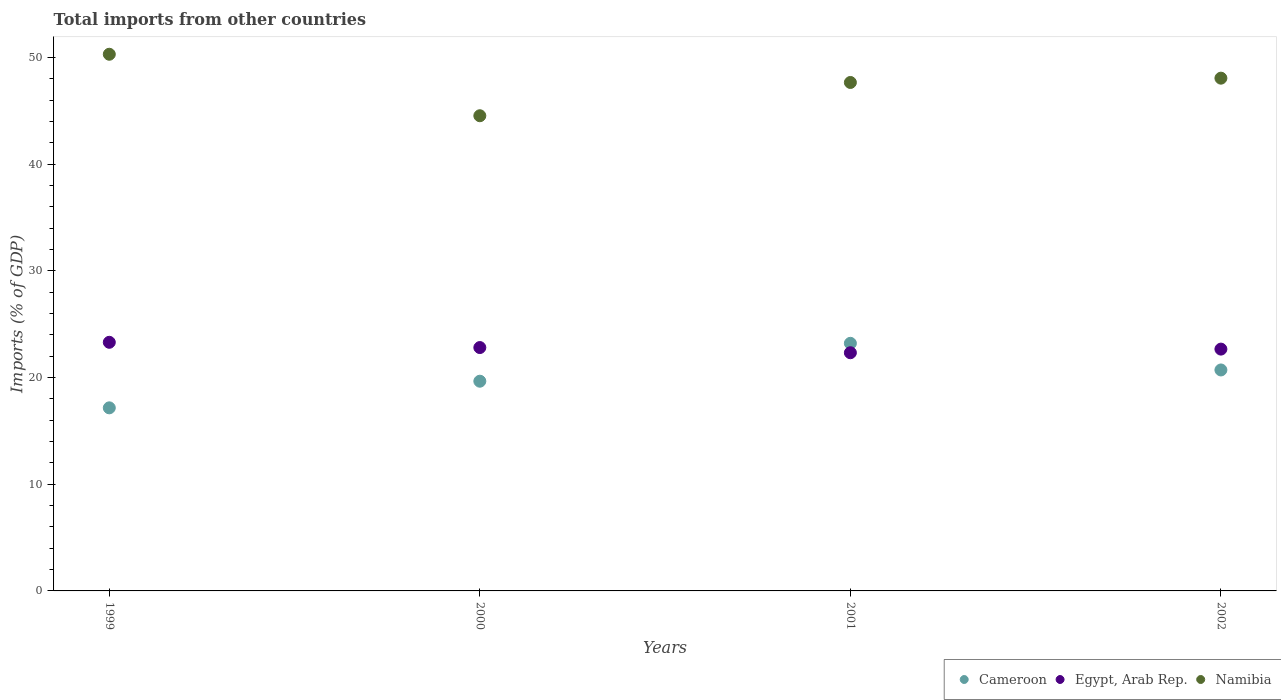How many different coloured dotlines are there?
Your response must be concise. 3. Is the number of dotlines equal to the number of legend labels?
Give a very brief answer. Yes. What is the total imports in Namibia in 2002?
Ensure brevity in your answer.  48.07. Across all years, what is the maximum total imports in Cameroon?
Keep it short and to the point. 23.21. Across all years, what is the minimum total imports in Namibia?
Make the answer very short. 44.55. In which year was the total imports in Cameroon maximum?
Make the answer very short. 2001. In which year was the total imports in Namibia minimum?
Your response must be concise. 2000. What is the total total imports in Egypt, Arab Rep. in the graph?
Offer a very short reply. 91.13. What is the difference between the total imports in Cameroon in 1999 and that in 2000?
Keep it short and to the point. -2.5. What is the difference between the total imports in Namibia in 1999 and the total imports in Egypt, Arab Rep. in 2000?
Your answer should be compact. 27.5. What is the average total imports in Namibia per year?
Keep it short and to the point. 47.65. In the year 2001, what is the difference between the total imports in Cameroon and total imports in Namibia?
Provide a succinct answer. -24.46. In how many years, is the total imports in Namibia greater than 16 %?
Make the answer very short. 4. What is the ratio of the total imports in Cameroon in 2000 to that in 2002?
Your answer should be compact. 0.95. Is the total imports in Egypt, Arab Rep. in 2000 less than that in 2002?
Offer a very short reply. No. Is the difference between the total imports in Cameroon in 2001 and 2002 greater than the difference between the total imports in Namibia in 2001 and 2002?
Offer a terse response. Yes. What is the difference between the highest and the second highest total imports in Cameroon?
Provide a short and direct response. 2.5. What is the difference between the highest and the lowest total imports in Cameroon?
Your answer should be compact. 6.05. In how many years, is the total imports in Cameroon greater than the average total imports in Cameroon taken over all years?
Your answer should be compact. 2. Is the sum of the total imports in Egypt, Arab Rep. in 1999 and 2000 greater than the maximum total imports in Namibia across all years?
Your response must be concise. No. Is it the case that in every year, the sum of the total imports in Egypt, Arab Rep. and total imports in Namibia  is greater than the total imports in Cameroon?
Your answer should be compact. Yes. Is the total imports in Namibia strictly less than the total imports in Egypt, Arab Rep. over the years?
Your answer should be very brief. No. Does the graph contain any zero values?
Provide a succinct answer. No. Does the graph contain grids?
Your answer should be compact. No. Where does the legend appear in the graph?
Make the answer very short. Bottom right. How many legend labels are there?
Give a very brief answer. 3. What is the title of the graph?
Provide a succinct answer. Total imports from other countries. What is the label or title of the X-axis?
Provide a short and direct response. Years. What is the label or title of the Y-axis?
Your answer should be compact. Imports (% of GDP). What is the Imports (% of GDP) in Cameroon in 1999?
Your response must be concise. 17.16. What is the Imports (% of GDP) in Egypt, Arab Rep. in 1999?
Keep it short and to the point. 23.31. What is the Imports (% of GDP) in Namibia in 1999?
Provide a short and direct response. 50.31. What is the Imports (% of GDP) of Cameroon in 2000?
Your answer should be compact. 19.66. What is the Imports (% of GDP) in Egypt, Arab Rep. in 2000?
Keep it short and to the point. 22.82. What is the Imports (% of GDP) of Namibia in 2000?
Your answer should be compact. 44.55. What is the Imports (% of GDP) of Cameroon in 2001?
Make the answer very short. 23.21. What is the Imports (% of GDP) of Egypt, Arab Rep. in 2001?
Provide a short and direct response. 22.33. What is the Imports (% of GDP) in Namibia in 2001?
Your response must be concise. 47.67. What is the Imports (% of GDP) of Cameroon in 2002?
Provide a succinct answer. 20.72. What is the Imports (% of GDP) in Egypt, Arab Rep. in 2002?
Make the answer very short. 22.67. What is the Imports (% of GDP) in Namibia in 2002?
Keep it short and to the point. 48.07. Across all years, what is the maximum Imports (% of GDP) of Cameroon?
Offer a very short reply. 23.21. Across all years, what is the maximum Imports (% of GDP) of Egypt, Arab Rep.?
Keep it short and to the point. 23.31. Across all years, what is the maximum Imports (% of GDP) in Namibia?
Keep it short and to the point. 50.31. Across all years, what is the minimum Imports (% of GDP) of Cameroon?
Keep it short and to the point. 17.16. Across all years, what is the minimum Imports (% of GDP) in Egypt, Arab Rep.?
Ensure brevity in your answer.  22.33. Across all years, what is the minimum Imports (% of GDP) of Namibia?
Ensure brevity in your answer.  44.55. What is the total Imports (% of GDP) in Cameroon in the graph?
Your answer should be very brief. 80.76. What is the total Imports (% of GDP) of Egypt, Arab Rep. in the graph?
Provide a short and direct response. 91.13. What is the total Imports (% of GDP) in Namibia in the graph?
Make the answer very short. 190.61. What is the difference between the Imports (% of GDP) of Cameroon in 1999 and that in 2000?
Ensure brevity in your answer.  -2.5. What is the difference between the Imports (% of GDP) of Egypt, Arab Rep. in 1999 and that in 2000?
Offer a terse response. 0.49. What is the difference between the Imports (% of GDP) in Namibia in 1999 and that in 2000?
Make the answer very short. 5.76. What is the difference between the Imports (% of GDP) of Cameroon in 1999 and that in 2001?
Your answer should be compact. -6.05. What is the difference between the Imports (% of GDP) of Egypt, Arab Rep. in 1999 and that in 2001?
Offer a very short reply. 0.98. What is the difference between the Imports (% of GDP) in Namibia in 1999 and that in 2001?
Keep it short and to the point. 2.65. What is the difference between the Imports (% of GDP) in Cameroon in 1999 and that in 2002?
Give a very brief answer. -3.55. What is the difference between the Imports (% of GDP) of Egypt, Arab Rep. in 1999 and that in 2002?
Offer a very short reply. 0.64. What is the difference between the Imports (% of GDP) of Namibia in 1999 and that in 2002?
Ensure brevity in your answer.  2.24. What is the difference between the Imports (% of GDP) in Cameroon in 2000 and that in 2001?
Offer a very short reply. -3.55. What is the difference between the Imports (% of GDP) of Egypt, Arab Rep. in 2000 and that in 2001?
Keep it short and to the point. 0.49. What is the difference between the Imports (% of GDP) in Namibia in 2000 and that in 2001?
Offer a terse response. -3.12. What is the difference between the Imports (% of GDP) in Cameroon in 2000 and that in 2002?
Make the answer very short. -1.06. What is the difference between the Imports (% of GDP) in Egypt, Arab Rep. in 2000 and that in 2002?
Your answer should be compact. 0.15. What is the difference between the Imports (% of GDP) in Namibia in 2000 and that in 2002?
Ensure brevity in your answer.  -3.52. What is the difference between the Imports (% of GDP) in Cameroon in 2001 and that in 2002?
Provide a short and direct response. 2.5. What is the difference between the Imports (% of GDP) of Egypt, Arab Rep. in 2001 and that in 2002?
Keep it short and to the point. -0.34. What is the difference between the Imports (% of GDP) in Namibia in 2001 and that in 2002?
Offer a very short reply. -0.4. What is the difference between the Imports (% of GDP) in Cameroon in 1999 and the Imports (% of GDP) in Egypt, Arab Rep. in 2000?
Your answer should be very brief. -5.65. What is the difference between the Imports (% of GDP) in Cameroon in 1999 and the Imports (% of GDP) in Namibia in 2000?
Offer a very short reply. -27.39. What is the difference between the Imports (% of GDP) in Egypt, Arab Rep. in 1999 and the Imports (% of GDP) in Namibia in 2000?
Give a very brief answer. -21.24. What is the difference between the Imports (% of GDP) in Cameroon in 1999 and the Imports (% of GDP) in Egypt, Arab Rep. in 2001?
Offer a terse response. -5.17. What is the difference between the Imports (% of GDP) of Cameroon in 1999 and the Imports (% of GDP) of Namibia in 2001?
Your answer should be very brief. -30.51. What is the difference between the Imports (% of GDP) in Egypt, Arab Rep. in 1999 and the Imports (% of GDP) in Namibia in 2001?
Give a very brief answer. -24.36. What is the difference between the Imports (% of GDP) of Cameroon in 1999 and the Imports (% of GDP) of Egypt, Arab Rep. in 2002?
Your answer should be compact. -5.51. What is the difference between the Imports (% of GDP) of Cameroon in 1999 and the Imports (% of GDP) of Namibia in 2002?
Provide a succinct answer. -30.91. What is the difference between the Imports (% of GDP) in Egypt, Arab Rep. in 1999 and the Imports (% of GDP) in Namibia in 2002?
Give a very brief answer. -24.76. What is the difference between the Imports (% of GDP) in Cameroon in 2000 and the Imports (% of GDP) in Egypt, Arab Rep. in 2001?
Offer a terse response. -2.67. What is the difference between the Imports (% of GDP) in Cameroon in 2000 and the Imports (% of GDP) in Namibia in 2001?
Your response must be concise. -28.01. What is the difference between the Imports (% of GDP) in Egypt, Arab Rep. in 2000 and the Imports (% of GDP) in Namibia in 2001?
Your answer should be very brief. -24.85. What is the difference between the Imports (% of GDP) of Cameroon in 2000 and the Imports (% of GDP) of Egypt, Arab Rep. in 2002?
Keep it short and to the point. -3.01. What is the difference between the Imports (% of GDP) in Cameroon in 2000 and the Imports (% of GDP) in Namibia in 2002?
Your answer should be compact. -28.41. What is the difference between the Imports (% of GDP) of Egypt, Arab Rep. in 2000 and the Imports (% of GDP) of Namibia in 2002?
Offer a terse response. -25.26. What is the difference between the Imports (% of GDP) of Cameroon in 2001 and the Imports (% of GDP) of Egypt, Arab Rep. in 2002?
Make the answer very short. 0.54. What is the difference between the Imports (% of GDP) of Cameroon in 2001 and the Imports (% of GDP) of Namibia in 2002?
Keep it short and to the point. -24.86. What is the difference between the Imports (% of GDP) of Egypt, Arab Rep. in 2001 and the Imports (% of GDP) of Namibia in 2002?
Offer a very short reply. -25.74. What is the average Imports (% of GDP) of Cameroon per year?
Give a very brief answer. 20.19. What is the average Imports (% of GDP) of Egypt, Arab Rep. per year?
Your response must be concise. 22.78. What is the average Imports (% of GDP) in Namibia per year?
Give a very brief answer. 47.65. In the year 1999, what is the difference between the Imports (% of GDP) of Cameroon and Imports (% of GDP) of Egypt, Arab Rep.?
Give a very brief answer. -6.15. In the year 1999, what is the difference between the Imports (% of GDP) of Cameroon and Imports (% of GDP) of Namibia?
Make the answer very short. -33.15. In the year 1999, what is the difference between the Imports (% of GDP) in Egypt, Arab Rep. and Imports (% of GDP) in Namibia?
Your response must be concise. -27.01. In the year 2000, what is the difference between the Imports (% of GDP) of Cameroon and Imports (% of GDP) of Egypt, Arab Rep.?
Ensure brevity in your answer.  -3.16. In the year 2000, what is the difference between the Imports (% of GDP) of Cameroon and Imports (% of GDP) of Namibia?
Your answer should be compact. -24.89. In the year 2000, what is the difference between the Imports (% of GDP) of Egypt, Arab Rep. and Imports (% of GDP) of Namibia?
Keep it short and to the point. -21.73. In the year 2001, what is the difference between the Imports (% of GDP) in Cameroon and Imports (% of GDP) in Egypt, Arab Rep.?
Provide a short and direct response. 0.88. In the year 2001, what is the difference between the Imports (% of GDP) in Cameroon and Imports (% of GDP) in Namibia?
Offer a very short reply. -24.46. In the year 2001, what is the difference between the Imports (% of GDP) of Egypt, Arab Rep. and Imports (% of GDP) of Namibia?
Give a very brief answer. -25.34. In the year 2002, what is the difference between the Imports (% of GDP) in Cameroon and Imports (% of GDP) in Egypt, Arab Rep.?
Give a very brief answer. -1.95. In the year 2002, what is the difference between the Imports (% of GDP) in Cameroon and Imports (% of GDP) in Namibia?
Ensure brevity in your answer.  -27.36. In the year 2002, what is the difference between the Imports (% of GDP) in Egypt, Arab Rep. and Imports (% of GDP) in Namibia?
Your answer should be very brief. -25.4. What is the ratio of the Imports (% of GDP) of Cameroon in 1999 to that in 2000?
Your response must be concise. 0.87. What is the ratio of the Imports (% of GDP) in Egypt, Arab Rep. in 1999 to that in 2000?
Provide a succinct answer. 1.02. What is the ratio of the Imports (% of GDP) in Namibia in 1999 to that in 2000?
Provide a short and direct response. 1.13. What is the ratio of the Imports (% of GDP) in Cameroon in 1999 to that in 2001?
Provide a succinct answer. 0.74. What is the ratio of the Imports (% of GDP) of Egypt, Arab Rep. in 1999 to that in 2001?
Provide a succinct answer. 1.04. What is the ratio of the Imports (% of GDP) in Namibia in 1999 to that in 2001?
Your response must be concise. 1.06. What is the ratio of the Imports (% of GDP) in Cameroon in 1999 to that in 2002?
Your answer should be very brief. 0.83. What is the ratio of the Imports (% of GDP) in Egypt, Arab Rep. in 1999 to that in 2002?
Provide a short and direct response. 1.03. What is the ratio of the Imports (% of GDP) in Namibia in 1999 to that in 2002?
Your answer should be compact. 1.05. What is the ratio of the Imports (% of GDP) in Cameroon in 2000 to that in 2001?
Provide a short and direct response. 0.85. What is the ratio of the Imports (% of GDP) in Egypt, Arab Rep. in 2000 to that in 2001?
Keep it short and to the point. 1.02. What is the ratio of the Imports (% of GDP) of Namibia in 2000 to that in 2001?
Your answer should be compact. 0.93. What is the ratio of the Imports (% of GDP) of Cameroon in 2000 to that in 2002?
Make the answer very short. 0.95. What is the ratio of the Imports (% of GDP) in Egypt, Arab Rep. in 2000 to that in 2002?
Your response must be concise. 1.01. What is the ratio of the Imports (% of GDP) in Namibia in 2000 to that in 2002?
Your response must be concise. 0.93. What is the ratio of the Imports (% of GDP) in Cameroon in 2001 to that in 2002?
Provide a short and direct response. 1.12. What is the ratio of the Imports (% of GDP) of Egypt, Arab Rep. in 2001 to that in 2002?
Offer a very short reply. 0.98. What is the difference between the highest and the second highest Imports (% of GDP) in Cameroon?
Your answer should be very brief. 2.5. What is the difference between the highest and the second highest Imports (% of GDP) of Egypt, Arab Rep.?
Provide a short and direct response. 0.49. What is the difference between the highest and the second highest Imports (% of GDP) of Namibia?
Ensure brevity in your answer.  2.24. What is the difference between the highest and the lowest Imports (% of GDP) in Cameroon?
Give a very brief answer. 6.05. What is the difference between the highest and the lowest Imports (% of GDP) in Egypt, Arab Rep.?
Give a very brief answer. 0.98. What is the difference between the highest and the lowest Imports (% of GDP) in Namibia?
Ensure brevity in your answer.  5.76. 